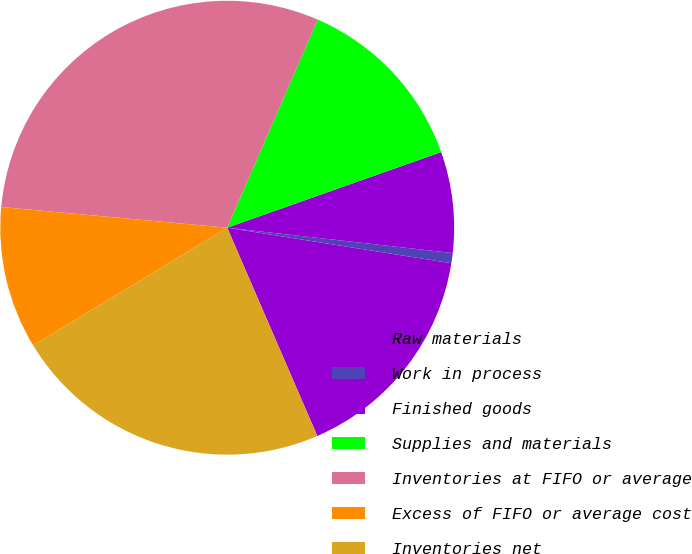Convert chart. <chart><loc_0><loc_0><loc_500><loc_500><pie_chart><fcel>Raw materials<fcel>Work in process<fcel>Finished goods<fcel>Supplies and materials<fcel>Inventories at FIFO or average<fcel>Excess of FIFO or average cost<fcel>Inventories net<nl><fcel>16.0%<fcel>0.72%<fcel>7.19%<fcel>13.06%<fcel>30.08%<fcel>10.13%<fcel>22.82%<nl></chart> 